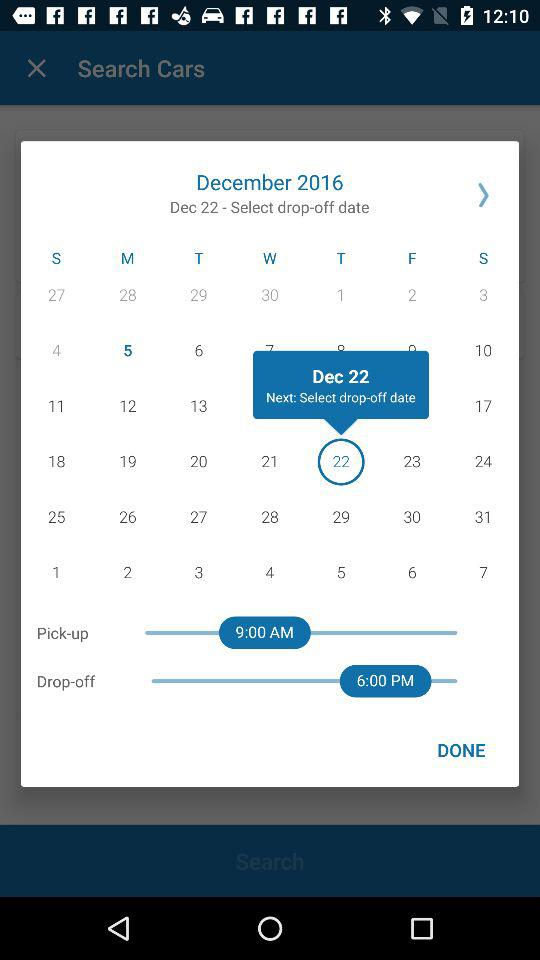What is the "Pick-up" time? The "Pick-up" time is 9:00 AM. 